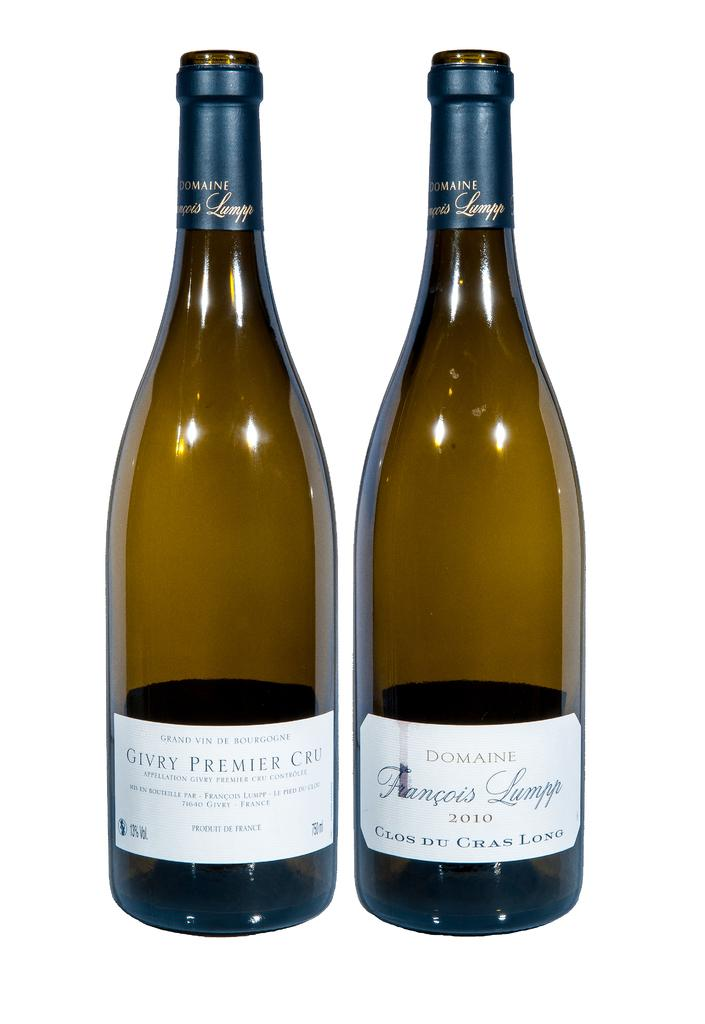Provide a one-sentence caption for the provided image. A bottle of Givry Premier Cru wine sits next to another bottle of wine. 